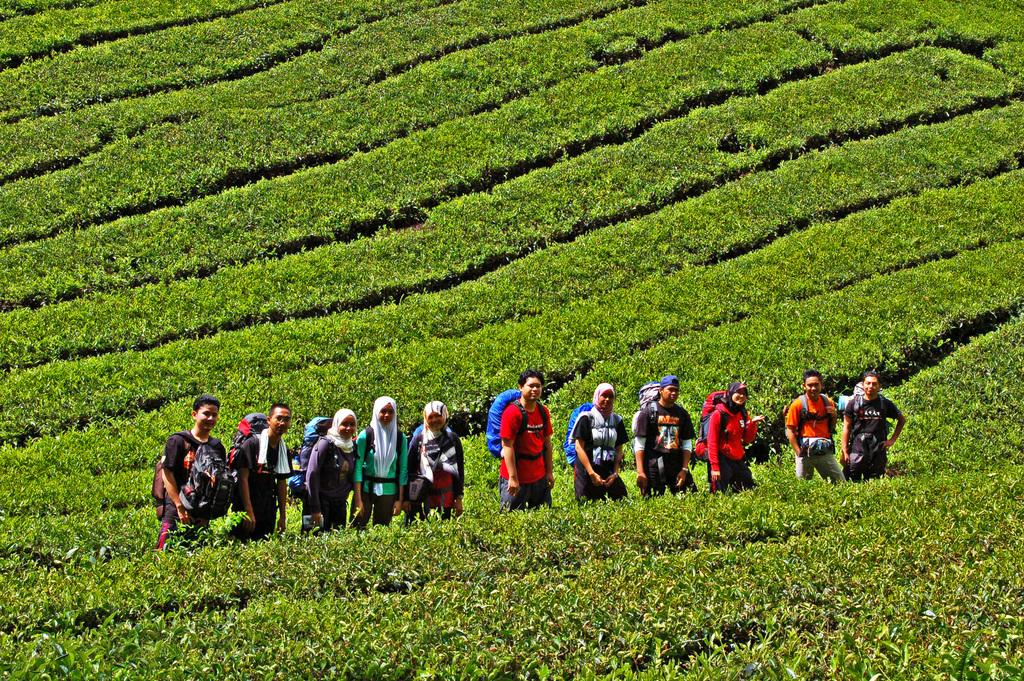What is the main subject of the image? The main subject of the image is the persons standing in the middle. What can be seen on either side of the persons? There is plantation on either side of the persons. Where is the plantation located? The plantation is on the land. What type of pollution can be seen in the image? There is no pollution visible in the image; it features persons standing amidst plantations on the land. 